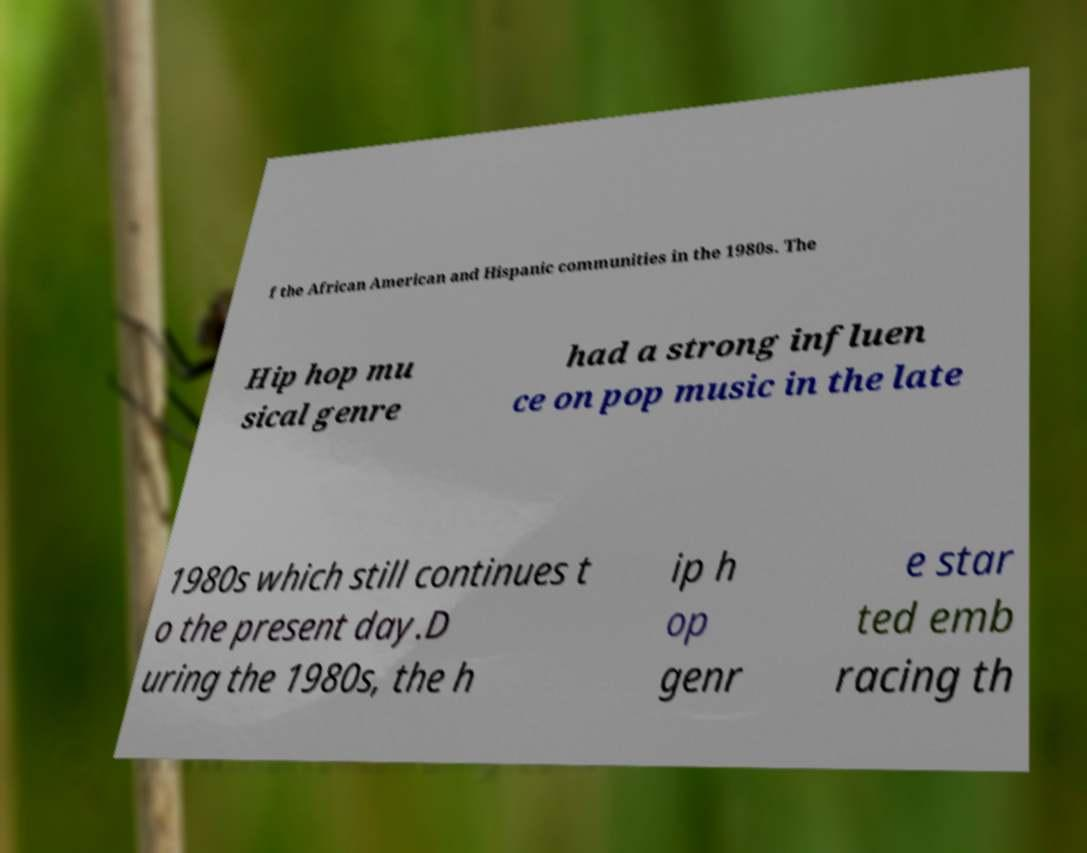Please read and relay the text visible in this image. What does it say? f the African American and Hispanic communities in the 1980s. The Hip hop mu sical genre had a strong influen ce on pop music in the late 1980s which still continues t o the present day.D uring the 1980s, the h ip h op genr e star ted emb racing th 